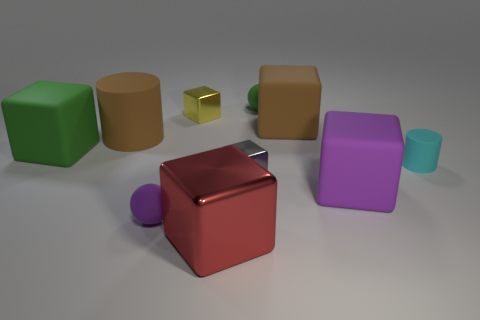There is a green object that is the same shape as the large purple rubber thing; what size is it?
Offer a terse response. Large. Are the green object that is right of the large cylinder and the small cylinder made of the same material?
Ensure brevity in your answer.  Yes. There is a block that is both in front of the gray cube and to the left of the big brown rubber cube; how big is it?
Keep it short and to the point. Large. There is a matte block in front of the tiny cylinder; what is its size?
Provide a succinct answer. Large. The big rubber object that is the same color as the big cylinder is what shape?
Provide a short and direct response. Cube. What is the shape of the tiny metal thing that is behind the big block behind the rubber cylinder that is to the left of the yellow metal cube?
Make the answer very short. Cube. How many other objects are there of the same shape as the cyan object?
Make the answer very short. 1. What number of rubber objects are either green things or small spheres?
Your answer should be compact. 3. What is the material of the tiny block behind the tiny cube that is to the right of the red object?
Your answer should be very brief. Metal. Is the number of blocks behind the big cylinder greater than the number of small gray metallic objects?
Offer a terse response. Yes. 